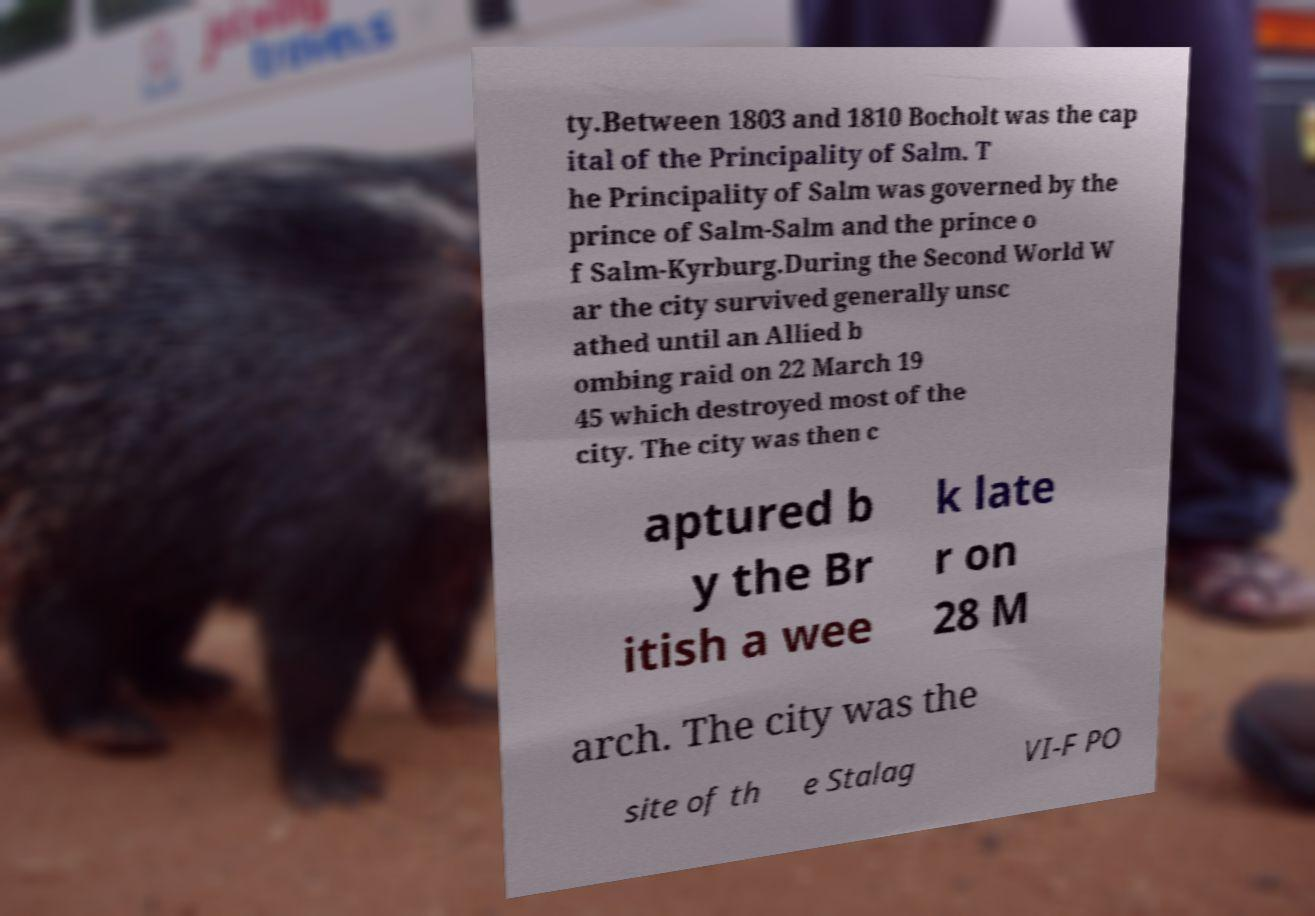Please identify and transcribe the text found in this image. ty.Between 1803 and 1810 Bocholt was the cap ital of the Principality of Salm. T he Principality of Salm was governed by the prince of Salm-Salm and the prince o f Salm-Kyrburg.During the Second World W ar the city survived generally unsc athed until an Allied b ombing raid on 22 March 19 45 which destroyed most of the city. The city was then c aptured b y the Br itish a wee k late r on 28 M arch. The city was the site of th e Stalag VI-F PO 